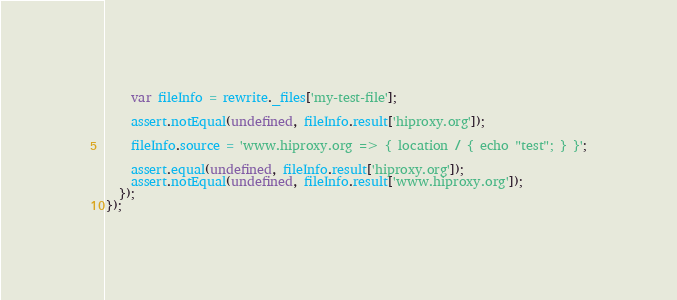<code> <loc_0><loc_0><loc_500><loc_500><_JavaScript_>
    var fileInfo = rewrite._files['my-test-file'];

    assert.notEqual(undefined, fileInfo.result['hiproxy.org']);

    fileInfo.source = 'www.hiproxy.org => { location / { echo "test"; } }';

    assert.equal(undefined, fileInfo.result['hiproxy.org']);
    assert.notEqual(undefined, fileInfo.result['www.hiproxy.org']);
  });
});
</code> 